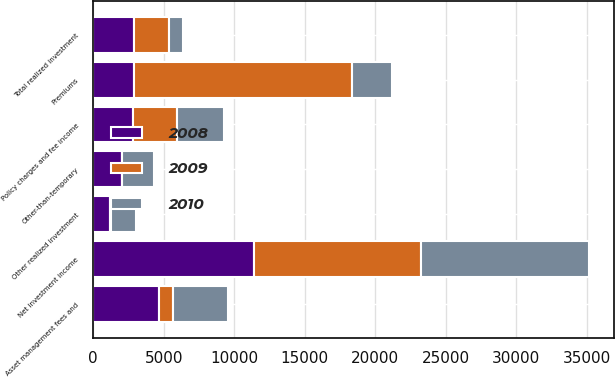Convert chart to OTSL. <chart><loc_0><loc_0><loc_500><loc_500><stacked_bar_chart><ecel><fcel>Premiums<fcel>Policy charges and fee income<fcel>Net investment income<fcel>Asset management fees and<fcel>Other-than-temporary<fcel>Other realized investment<fcel>Total realized investment<nl><fcel>2010<fcel>2865<fcel>3321<fcel>11875<fcel>3908<fcel>2284<fcel>1782<fcel>1050<nl><fcel>2008<fcel>2865<fcel>2833<fcel>11403<fcel>4682<fcel>2027<fcel>1203<fcel>2897<nl><fcel>2009<fcel>15468<fcel>3138<fcel>11861<fcel>980<fcel>0<fcel>60<fcel>2457<nl></chart> 